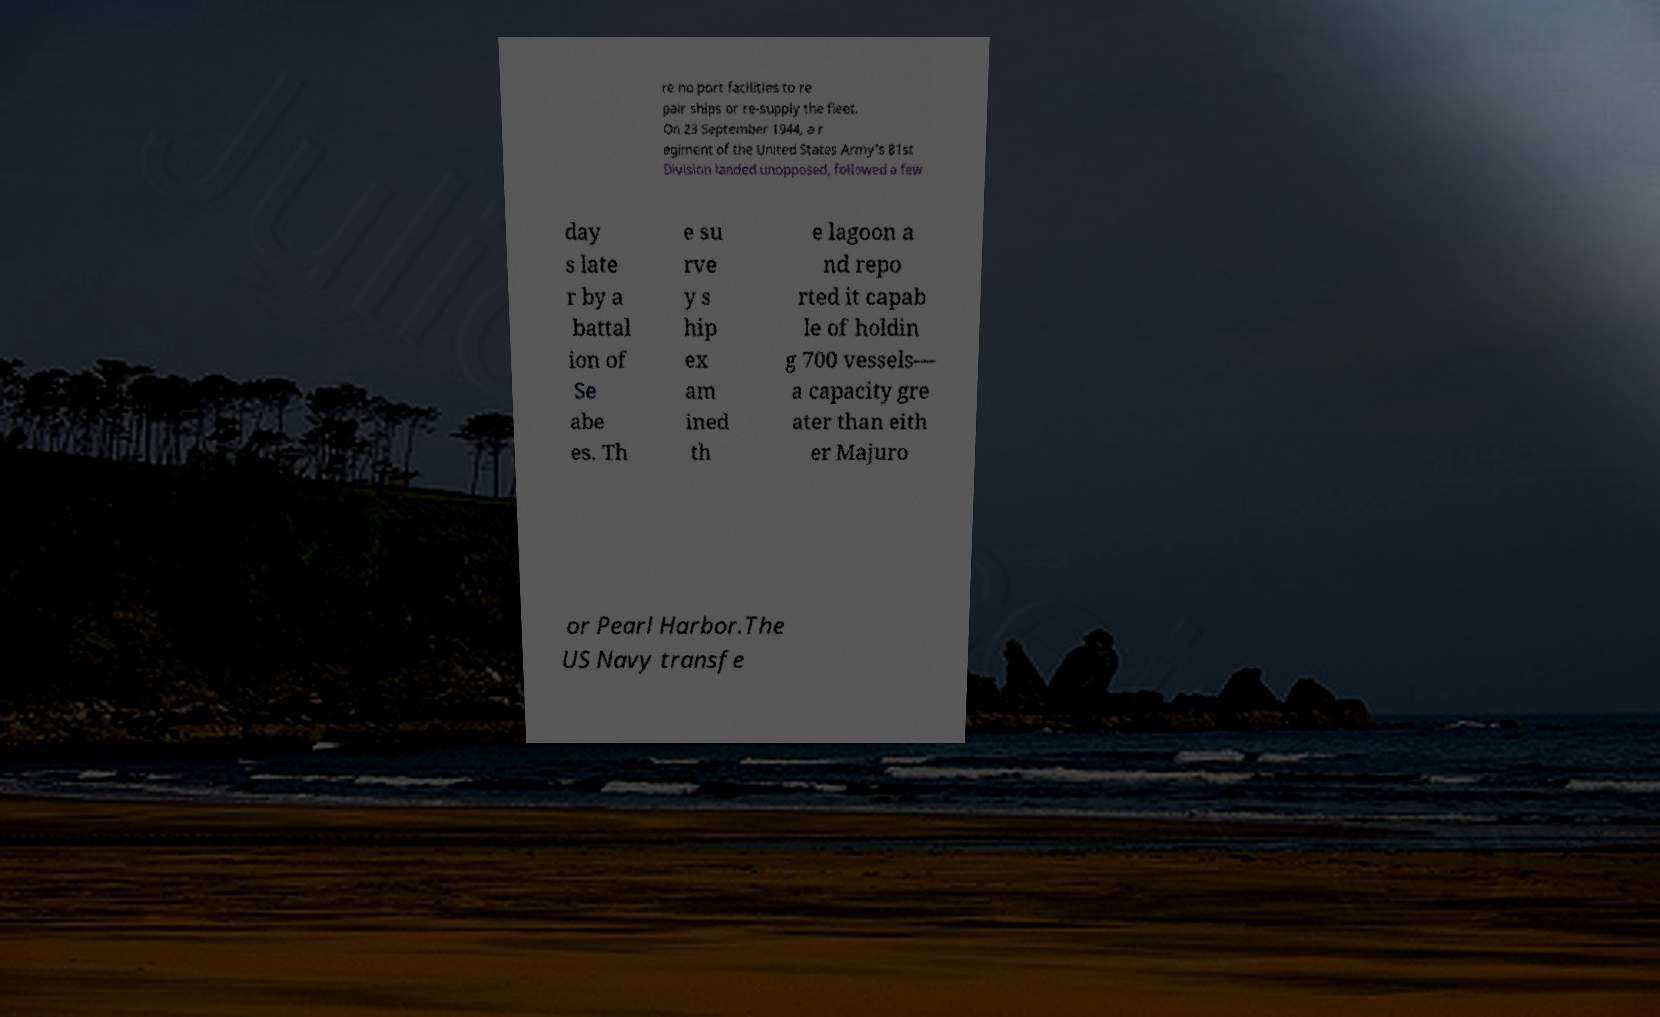Could you assist in decoding the text presented in this image and type it out clearly? re no port facilities to re pair ships or re-supply the fleet. On 23 September 1944, a r egiment of the United States Army's 81st Division landed unopposed, followed a few day s late r by a battal ion of Se abe es. Th e su rve y s hip ex am ined th e lagoon a nd repo rted it capab le of holdin g 700 vessels— a capacity gre ater than eith er Majuro or Pearl Harbor.The US Navy transfe 